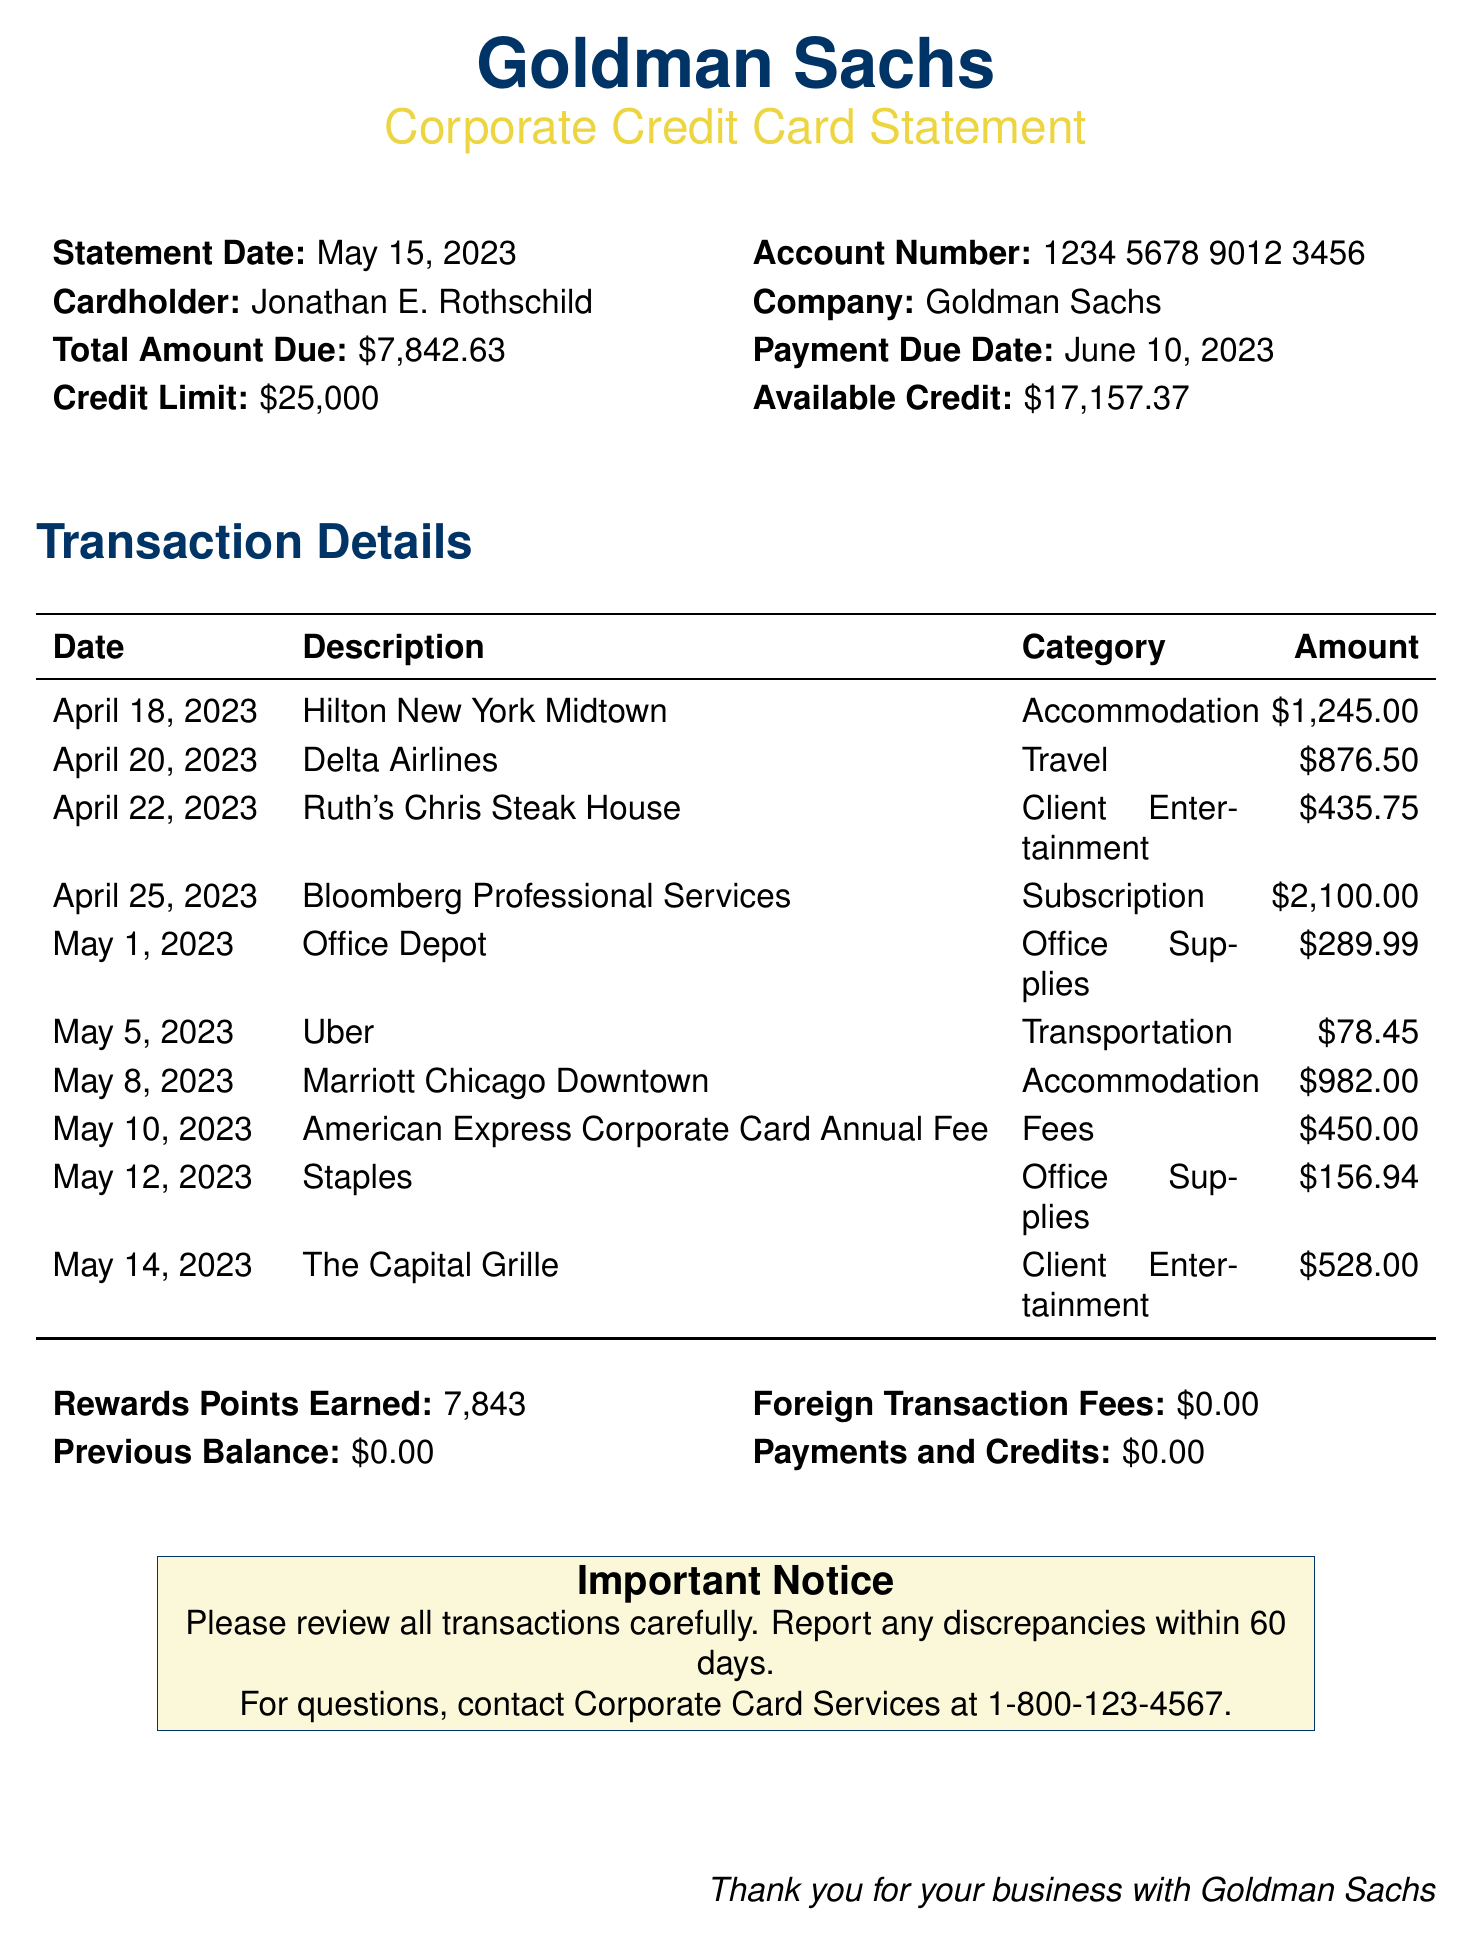What is the statement date? The statement date is clearly indicated in the document under the statement details.
Answer: May 15, 2023 Who is the cardholder? The cardholder's name is specified near the top of the document, alongside the account information.
Answer: Jonathan E. Rothschild What is the total amount due? The total amount due is prominently mentioned on the statement and is an important piece of information.
Answer: $7,842.63 How many rewards points were earned? The total rewards points earned is noted in a summary section towards the end of the document.
Answer: 7,843 What category does the transaction for Uber fall under? Each transaction has an associated category that is listed next to the transaction details.
Answer: Transportation What is the credit limit on the account? The credit limit is specified in the account summary section of the document.
Answer: $25,000 How much was spent on client entertainment? The calculation involves summing the amounts for all client entertainment transactions listed in the document.
Answer: $963.75 When is the payment due date? The payment due date is stated clearly in the account summary area of the document.
Answer: June 10, 2023 What was the amount for the Bloomberg Professional Services subscription? This amount is detailed in the transaction summary and indicates a subscription expense.
Answer: $2,100.00 